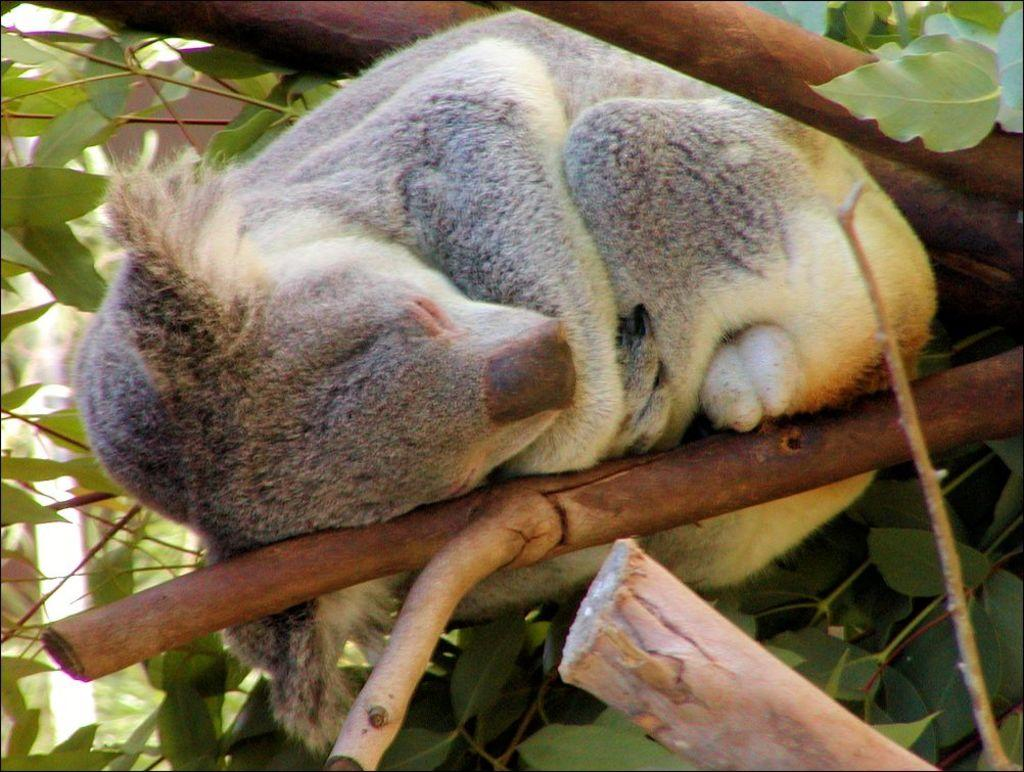What is on the tree branch in the image? There is an animal on a tree branch in the image. What can be seen in the background of the image? There is a group of leaves in the background of the image. How much honey is the animal collecting from the tree in the image? There is no honey or indication of honey collection in the image. 